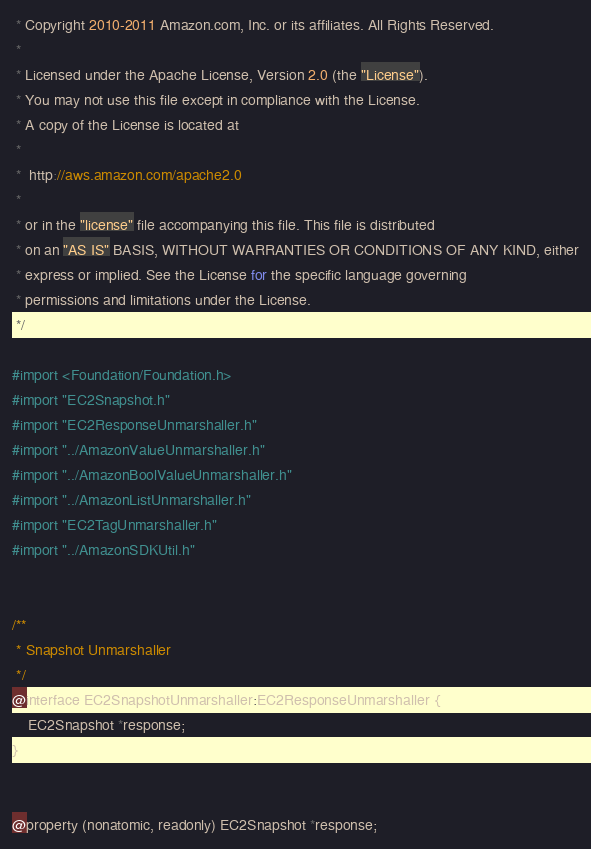<code> <loc_0><loc_0><loc_500><loc_500><_C_> * Copyright 2010-2011 Amazon.com, Inc. or its affiliates. All Rights Reserved.
 *
 * Licensed under the Apache License, Version 2.0 (the "License").
 * You may not use this file except in compliance with the License.
 * A copy of the License is located at
 *
 *  http://aws.amazon.com/apache2.0
 *
 * or in the "license" file accompanying this file. This file is distributed
 * on an "AS IS" BASIS, WITHOUT WARRANTIES OR CONDITIONS OF ANY KIND, either
 * express or implied. See the License for the specific language governing
 * permissions and limitations under the License.
 */

#import <Foundation/Foundation.h>
#import "EC2Snapshot.h"
#import "EC2ResponseUnmarshaller.h"
#import "../AmazonValueUnmarshaller.h"
#import "../AmazonBoolValueUnmarshaller.h"
#import "../AmazonListUnmarshaller.h"
#import "EC2TagUnmarshaller.h"
#import "../AmazonSDKUtil.h"


/**
 * Snapshot Unmarshaller
 */
@interface EC2SnapshotUnmarshaller:EC2ResponseUnmarshaller {
    EC2Snapshot *response;
}


@property (nonatomic, readonly) EC2Snapshot *response;

</code> 